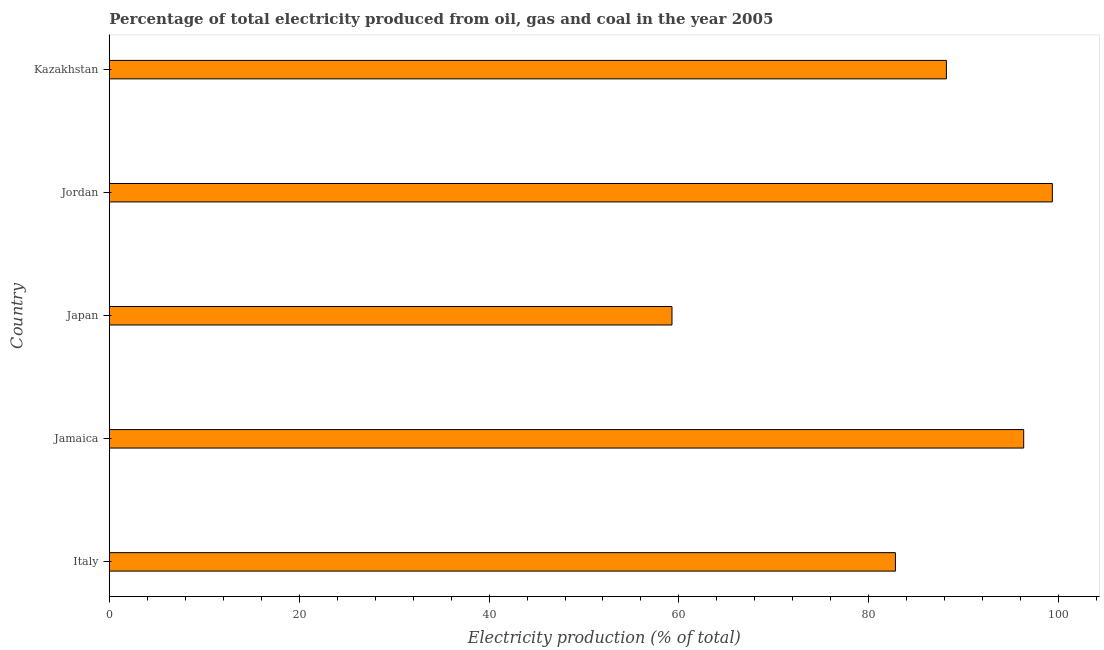What is the title of the graph?
Your answer should be very brief. Percentage of total electricity produced from oil, gas and coal in the year 2005. What is the label or title of the X-axis?
Your answer should be compact. Electricity production (% of total). What is the label or title of the Y-axis?
Your answer should be compact. Country. What is the electricity production in Jamaica?
Provide a short and direct response. 96.31. Across all countries, what is the maximum electricity production?
Give a very brief answer. 99.33. Across all countries, what is the minimum electricity production?
Give a very brief answer. 59.27. In which country was the electricity production maximum?
Your response must be concise. Jordan. In which country was the electricity production minimum?
Keep it short and to the point. Japan. What is the sum of the electricity production?
Keep it short and to the point. 425.87. What is the difference between the electricity production in Japan and Jordan?
Your response must be concise. -40.06. What is the average electricity production per country?
Your response must be concise. 85.17. What is the median electricity production?
Offer a very short reply. 88.17. What is the ratio of the electricity production in Jamaica to that in Japan?
Your answer should be very brief. 1.62. Is the electricity production in Jamaica less than that in Kazakhstan?
Your response must be concise. No. Is the difference between the electricity production in Jordan and Kazakhstan greater than the difference between any two countries?
Give a very brief answer. No. What is the difference between the highest and the second highest electricity production?
Offer a terse response. 3.02. Is the sum of the electricity production in Jamaica and Japan greater than the maximum electricity production across all countries?
Make the answer very short. Yes. What is the difference between the highest and the lowest electricity production?
Your answer should be compact. 40.06. How many bars are there?
Make the answer very short. 5. Are all the bars in the graph horizontal?
Your answer should be very brief. Yes. What is the difference between two consecutive major ticks on the X-axis?
Offer a terse response. 20. Are the values on the major ticks of X-axis written in scientific E-notation?
Provide a succinct answer. No. What is the Electricity production (% of total) in Italy?
Your answer should be compact. 82.8. What is the Electricity production (% of total) of Jamaica?
Give a very brief answer. 96.31. What is the Electricity production (% of total) of Japan?
Ensure brevity in your answer.  59.27. What is the Electricity production (% of total) of Jordan?
Your answer should be compact. 99.33. What is the Electricity production (% of total) of Kazakhstan?
Ensure brevity in your answer.  88.17. What is the difference between the Electricity production (% of total) in Italy and Jamaica?
Keep it short and to the point. -13.51. What is the difference between the Electricity production (% of total) in Italy and Japan?
Give a very brief answer. 23.53. What is the difference between the Electricity production (% of total) in Italy and Jordan?
Offer a very short reply. -16.53. What is the difference between the Electricity production (% of total) in Italy and Kazakhstan?
Give a very brief answer. -5.37. What is the difference between the Electricity production (% of total) in Jamaica and Japan?
Offer a terse response. 37.04. What is the difference between the Electricity production (% of total) in Jamaica and Jordan?
Provide a short and direct response. -3.02. What is the difference between the Electricity production (% of total) in Jamaica and Kazakhstan?
Keep it short and to the point. 8.14. What is the difference between the Electricity production (% of total) in Japan and Jordan?
Give a very brief answer. -40.06. What is the difference between the Electricity production (% of total) in Japan and Kazakhstan?
Provide a succinct answer. -28.9. What is the difference between the Electricity production (% of total) in Jordan and Kazakhstan?
Offer a very short reply. 11.16. What is the ratio of the Electricity production (% of total) in Italy to that in Jamaica?
Ensure brevity in your answer.  0.86. What is the ratio of the Electricity production (% of total) in Italy to that in Japan?
Your answer should be very brief. 1.4. What is the ratio of the Electricity production (% of total) in Italy to that in Jordan?
Ensure brevity in your answer.  0.83. What is the ratio of the Electricity production (% of total) in Italy to that in Kazakhstan?
Your response must be concise. 0.94. What is the ratio of the Electricity production (% of total) in Jamaica to that in Japan?
Offer a very short reply. 1.62. What is the ratio of the Electricity production (% of total) in Jamaica to that in Jordan?
Your response must be concise. 0.97. What is the ratio of the Electricity production (% of total) in Jamaica to that in Kazakhstan?
Provide a short and direct response. 1.09. What is the ratio of the Electricity production (% of total) in Japan to that in Jordan?
Make the answer very short. 0.6. What is the ratio of the Electricity production (% of total) in Japan to that in Kazakhstan?
Make the answer very short. 0.67. What is the ratio of the Electricity production (% of total) in Jordan to that in Kazakhstan?
Your response must be concise. 1.13. 